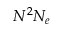Convert formula to latex. <formula><loc_0><loc_0><loc_500><loc_500>N ^ { 2 } N _ { e }</formula> 